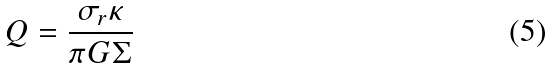Convert formula to latex. <formula><loc_0><loc_0><loc_500><loc_500>Q = \frac { \sigma _ { r } \kappa } { \pi G \Sigma }</formula> 